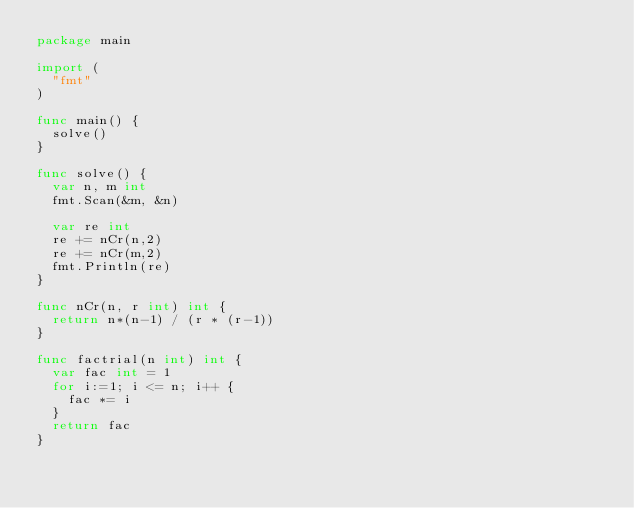<code> <loc_0><loc_0><loc_500><loc_500><_Go_>package main

import (
  "fmt"
)

func main() {
  solve()
}

func solve() {
  var n, m int
  fmt.Scan(&m, &n)
  
  var re int
  re += nCr(n,2)
  re += nCr(m,2)
  fmt.Println(re)
}

func nCr(n, r int) int {
  return n*(n-1) / (r * (r-1))
}

func factrial(n int) int {
  var fac int = 1
  for i:=1; i <= n; i++ {
    fac *= i
  }
  return fac
}</code> 